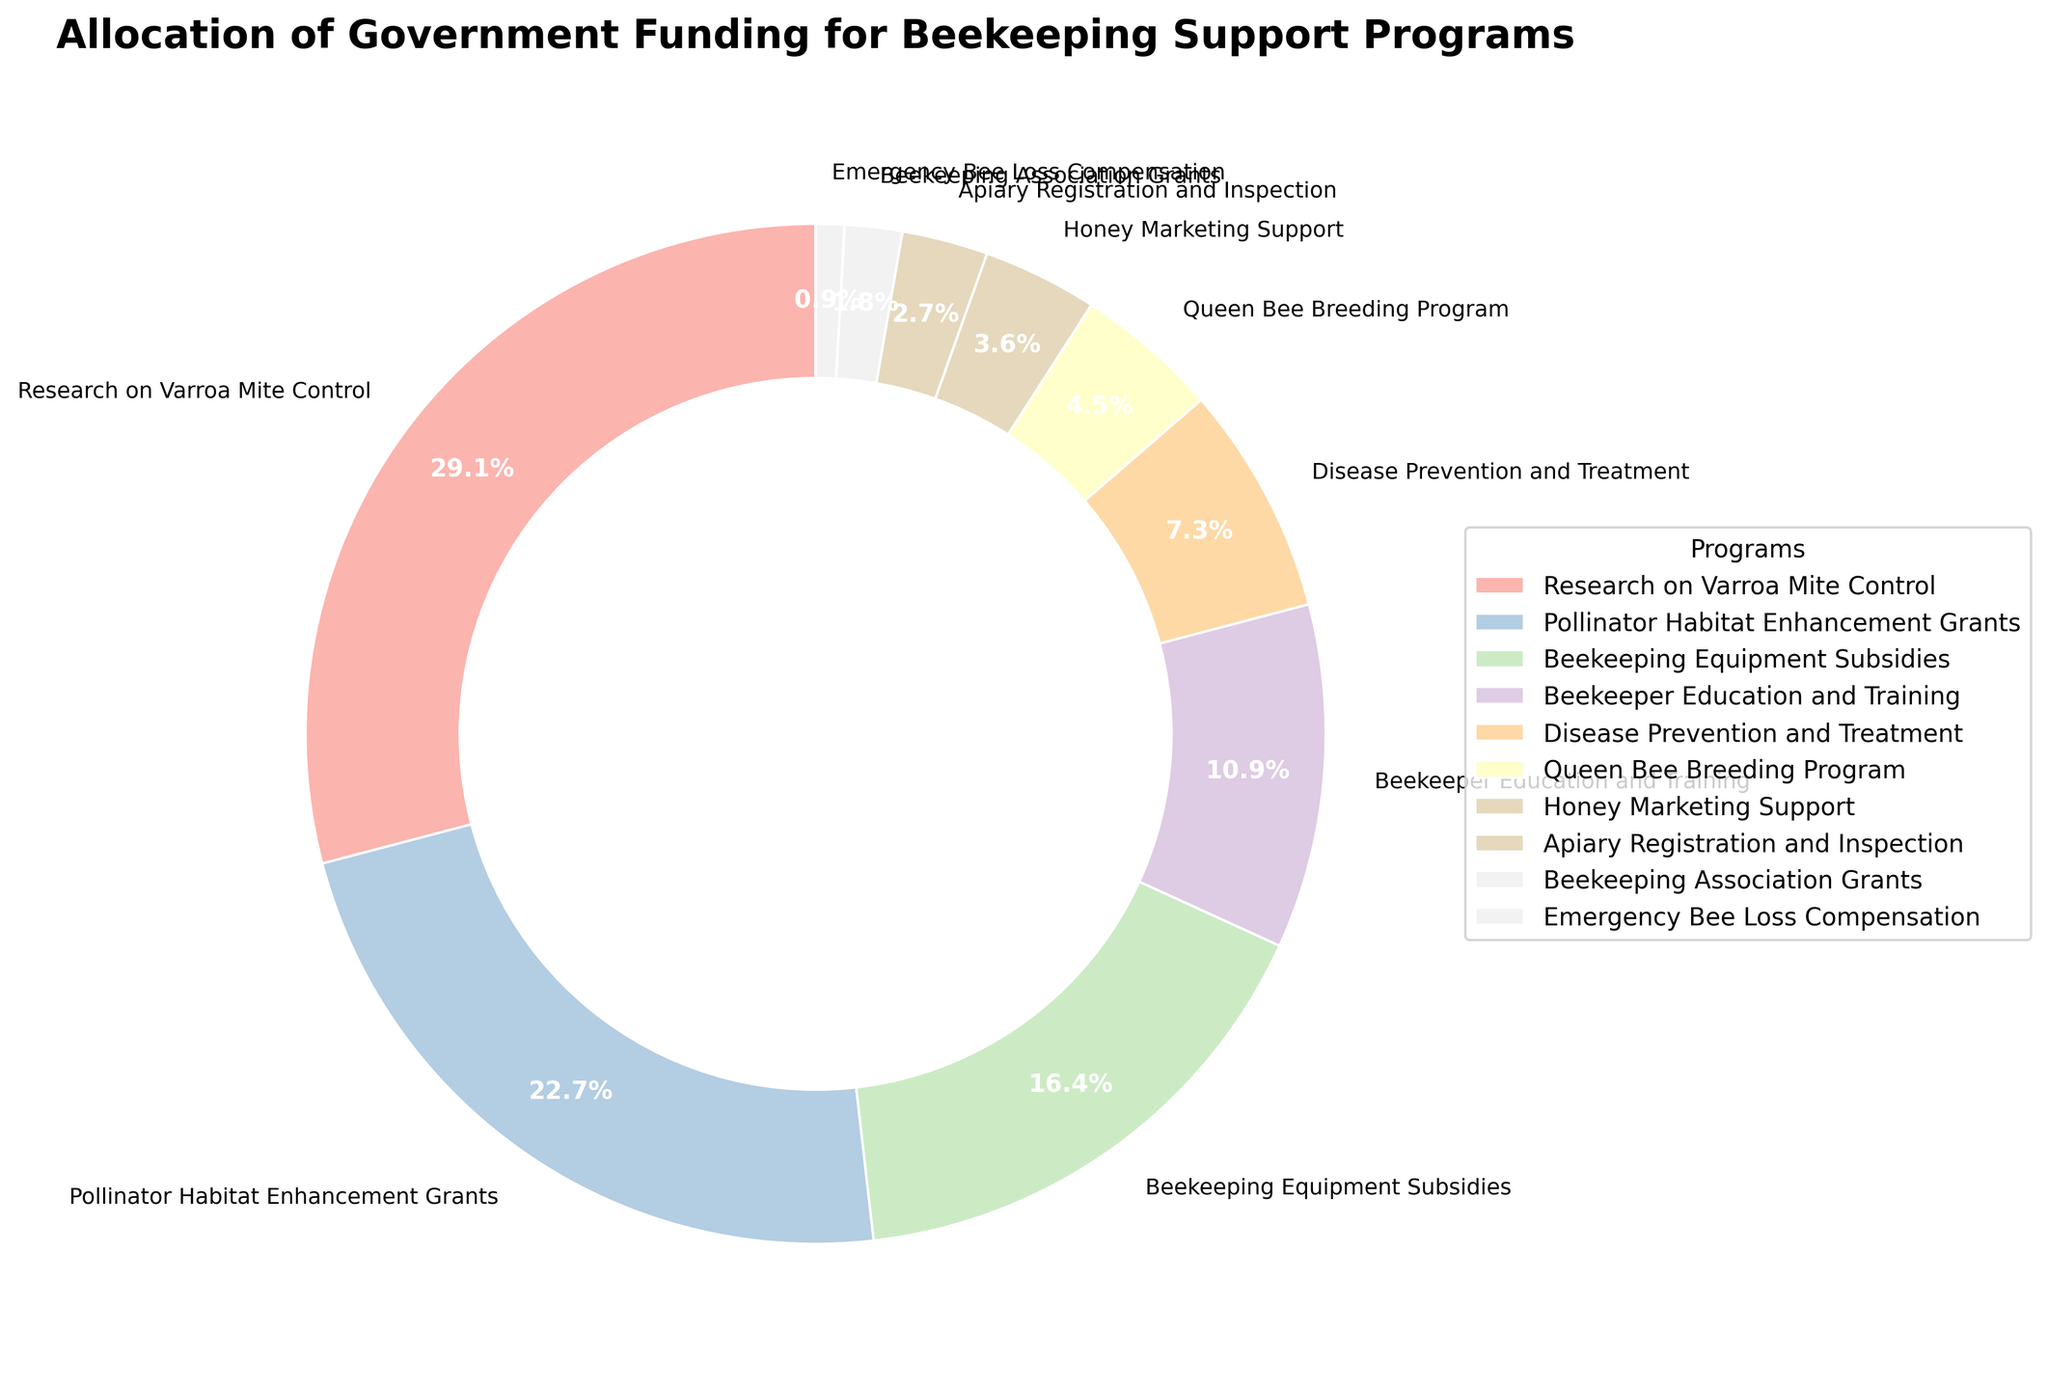Which program receives the highest funding allocation? The pie chart shows that "Research on Varroa Mite Control" occupies the largest segment, indicating it receives the highest funding.
Answer: Research on Varroa Mite Control What percentage of the total funding is allocated to Beekeeping Equipment Subsidies and Beekeeper Education and Training combined? Summing the percentages for Beekeeping Equipment Subsidies (18%) and Beekeeper Education and Training (12%) from the pie chart gives the total.
Answer: 30% How much more funding is allocated to Pollinator Habitat Enhancement Grants compared to Disease Prevention and Treatment? Pollinator Habitat Enhancement Grants receive 25%, and Disease Prevention and Treatment receives 8%. Subtracting 8 from 25 gives the difference.
Answer: 17% Which program has the smallest funding allocation, and what percentage does it receive? The pie chart indicates that "Emergency Bee Loss Compensation" has the smallest allocation.
Answer: Emergency Bee Loss Compensation, 1% Considering the programs that receive less than 5% of the funding, how many such programs are there? The pie chart segments for Apiary Registration and Inspection, Beekeeping Association Grants, and Emergency Bee Loss Compensation each represent less than 5%. Counting these segments gives the total.
Answer: 3 Is the funding for Queen Bee Breeding Program higher or lower than for Honey Marketing Support? The pie chart shows that Queen Bee Breeding Program (5%) has a higher allocation than Honey Marketing Support (4%).
Answer: Higher What is the combined percentage of funding allocated to programs related to disease control (Research on Varroa Mite Control and Disease Prevention and Treatment)? Adding the percentages for Research on Varroa Mite Control (32%) and Disease Prevention and Treatment (8%) gives the combined percentage.
Answer: 40% Which program receives a percentage of funding allocation that is close to the average percentage across all programs? The total funding allocation is 100%, divided by 10 programs gives an average of 10%. "Beekeeper Education and Training" at 12% is closest to this average.
Answer: Beekeeper Education and Training Out of all the funding allocations, which slice is visually represented with the second largest segment on the pie chart? The second largest segment on the pie chart is “Pollinator Habitat Enhancement Grants” at 25%.
Answer: Pollinator Habitat Enhancement Grants 